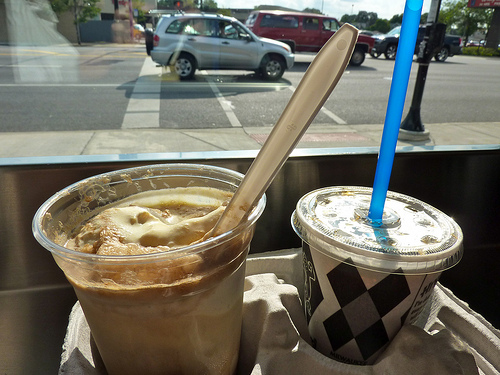<image>
Is there a car behind the drink? Yes. From this viewpoint, the car is positioned behind the drink, with the drink partially or fully occluding the car. Is there a car in the road? Yes. The car is contained within or inside the road, showing a containment relationship. 